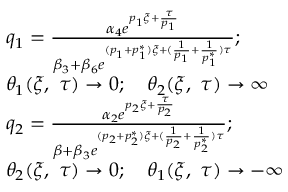Convert formula to latex. <formula><loc_0><loc_0><loc_500><loc_500>\begin{array} { r l } & { q _ { 1 } = \frac { \alpha _ { 4 } e ^ { p _ { 1 } \xi + \frac { \tau } { p _ { 1 } } } } { \beta _ { 3 } + \beta _ { 6 } e ^ { ( p _ { 1 } + p _ { 1 } ^ { * } ) \xi + ( \frac { 1 } { p _ { 1 } } + \frac { 1 } { p _ { 1 } ^ { * } } ) \tau } } ; } \\ & { \theta _ { 1 } ( \xi , \ \tau ) \to 0 ; \quad \theta _ { 2 } ( \xi , \ \tau ) \to \infty } \\ & { q _ { 2 } = \frac { \alpha _ { 2 } e ^ { p _ { 2 } \xi + \frac { \tau } { p _ { 2 } } } } { \beta + \beta _ { 3 } e ^ { ( p _ { 2 } + p _ { 2 } ^ { * } ) \xi + ( \frac { 1 } { p _ { 2 } } + \frac { 1 } { p _ { 2 } ^ { * } } ) \tau } } ; } \\ & { \theta _ { 2 } ( \xi , \ \tau ) \to 0 ; \quad \theta _ { 1 } ( \xi , \ \tau ) \to - \infty } \end{array}</formula> 